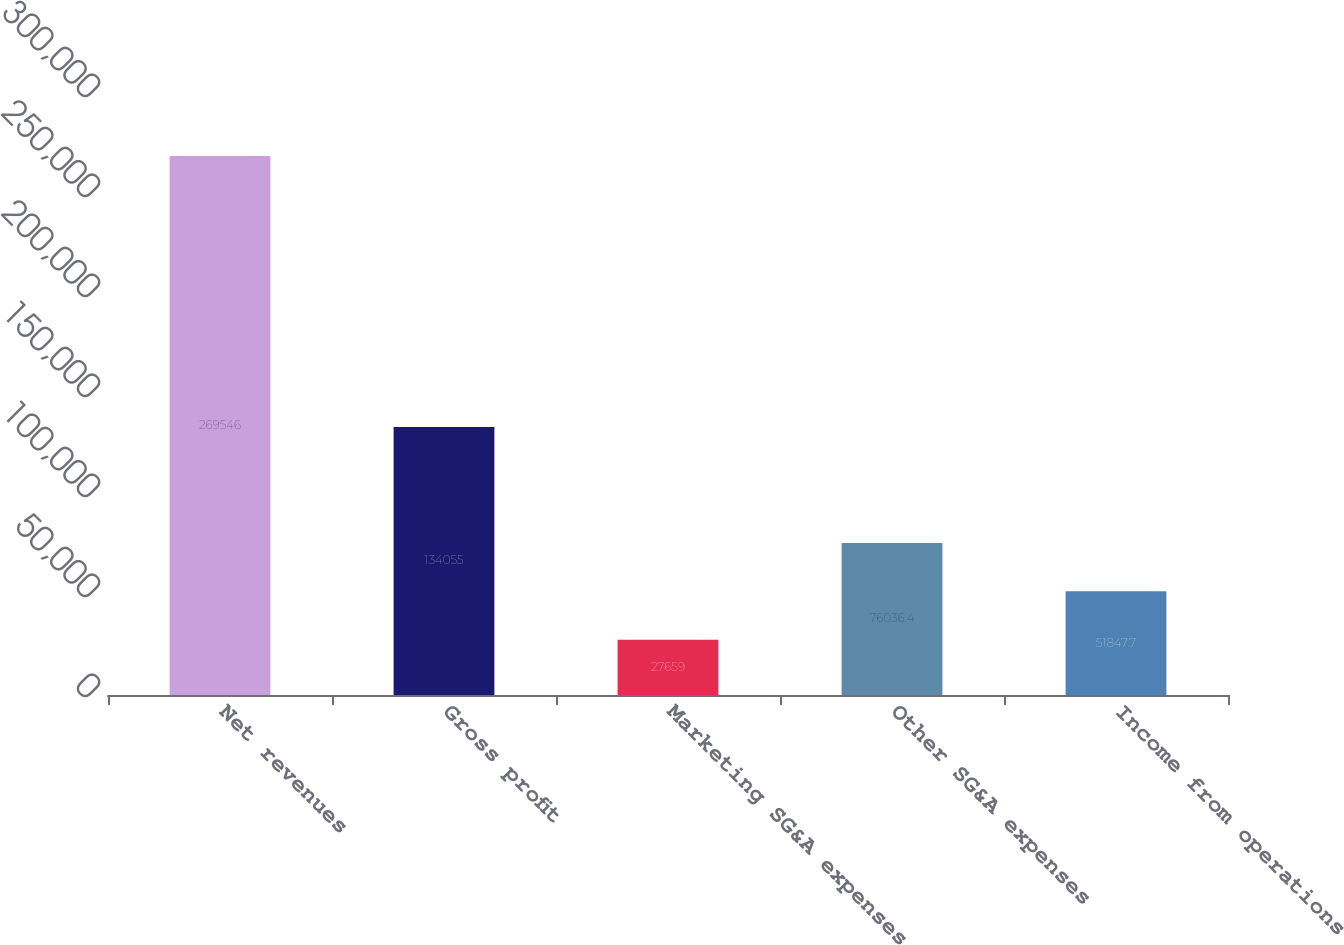Convert chart. <chart><loc_0><loc_0><loc_500><loc_500><bar_chart><fcel>Net revenues<fcel>Gross profit<fcel>Marketing SG&A expenses<fcel>Other SG&A expenses<fcel>Income from operations<nl><fcel>269546<fcel>134055<fcel>27659<fcel>76036.4<fcel>51847.7<nl></chart> 